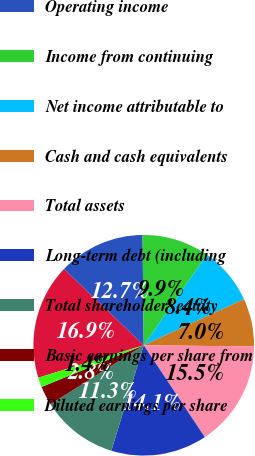Convert chart to OTSL. <chart><loc_0><loc_0><loc_500><loc_500><pie_chart><fcel>Net sales<fcel>Operating income<fcel>Income from continuing<fcel>Net income attributable to<fcel>Cash and cash equivalents<fcel>Total assets<fcel>Long-term debt (including<fcel>Total shareholder' equity<fcel>Basic earnings per share from<fcel>Diluted earnings per share<nl><fcel>16.9%<fcel>12.68%<fcel>9.86%<fcel>8.45%<fcel>7.04%<fcel>15.49%<fcel>14.08%<fcel>11.27%<fcel>2.82%<fcel>1.41%<nl></chart> 